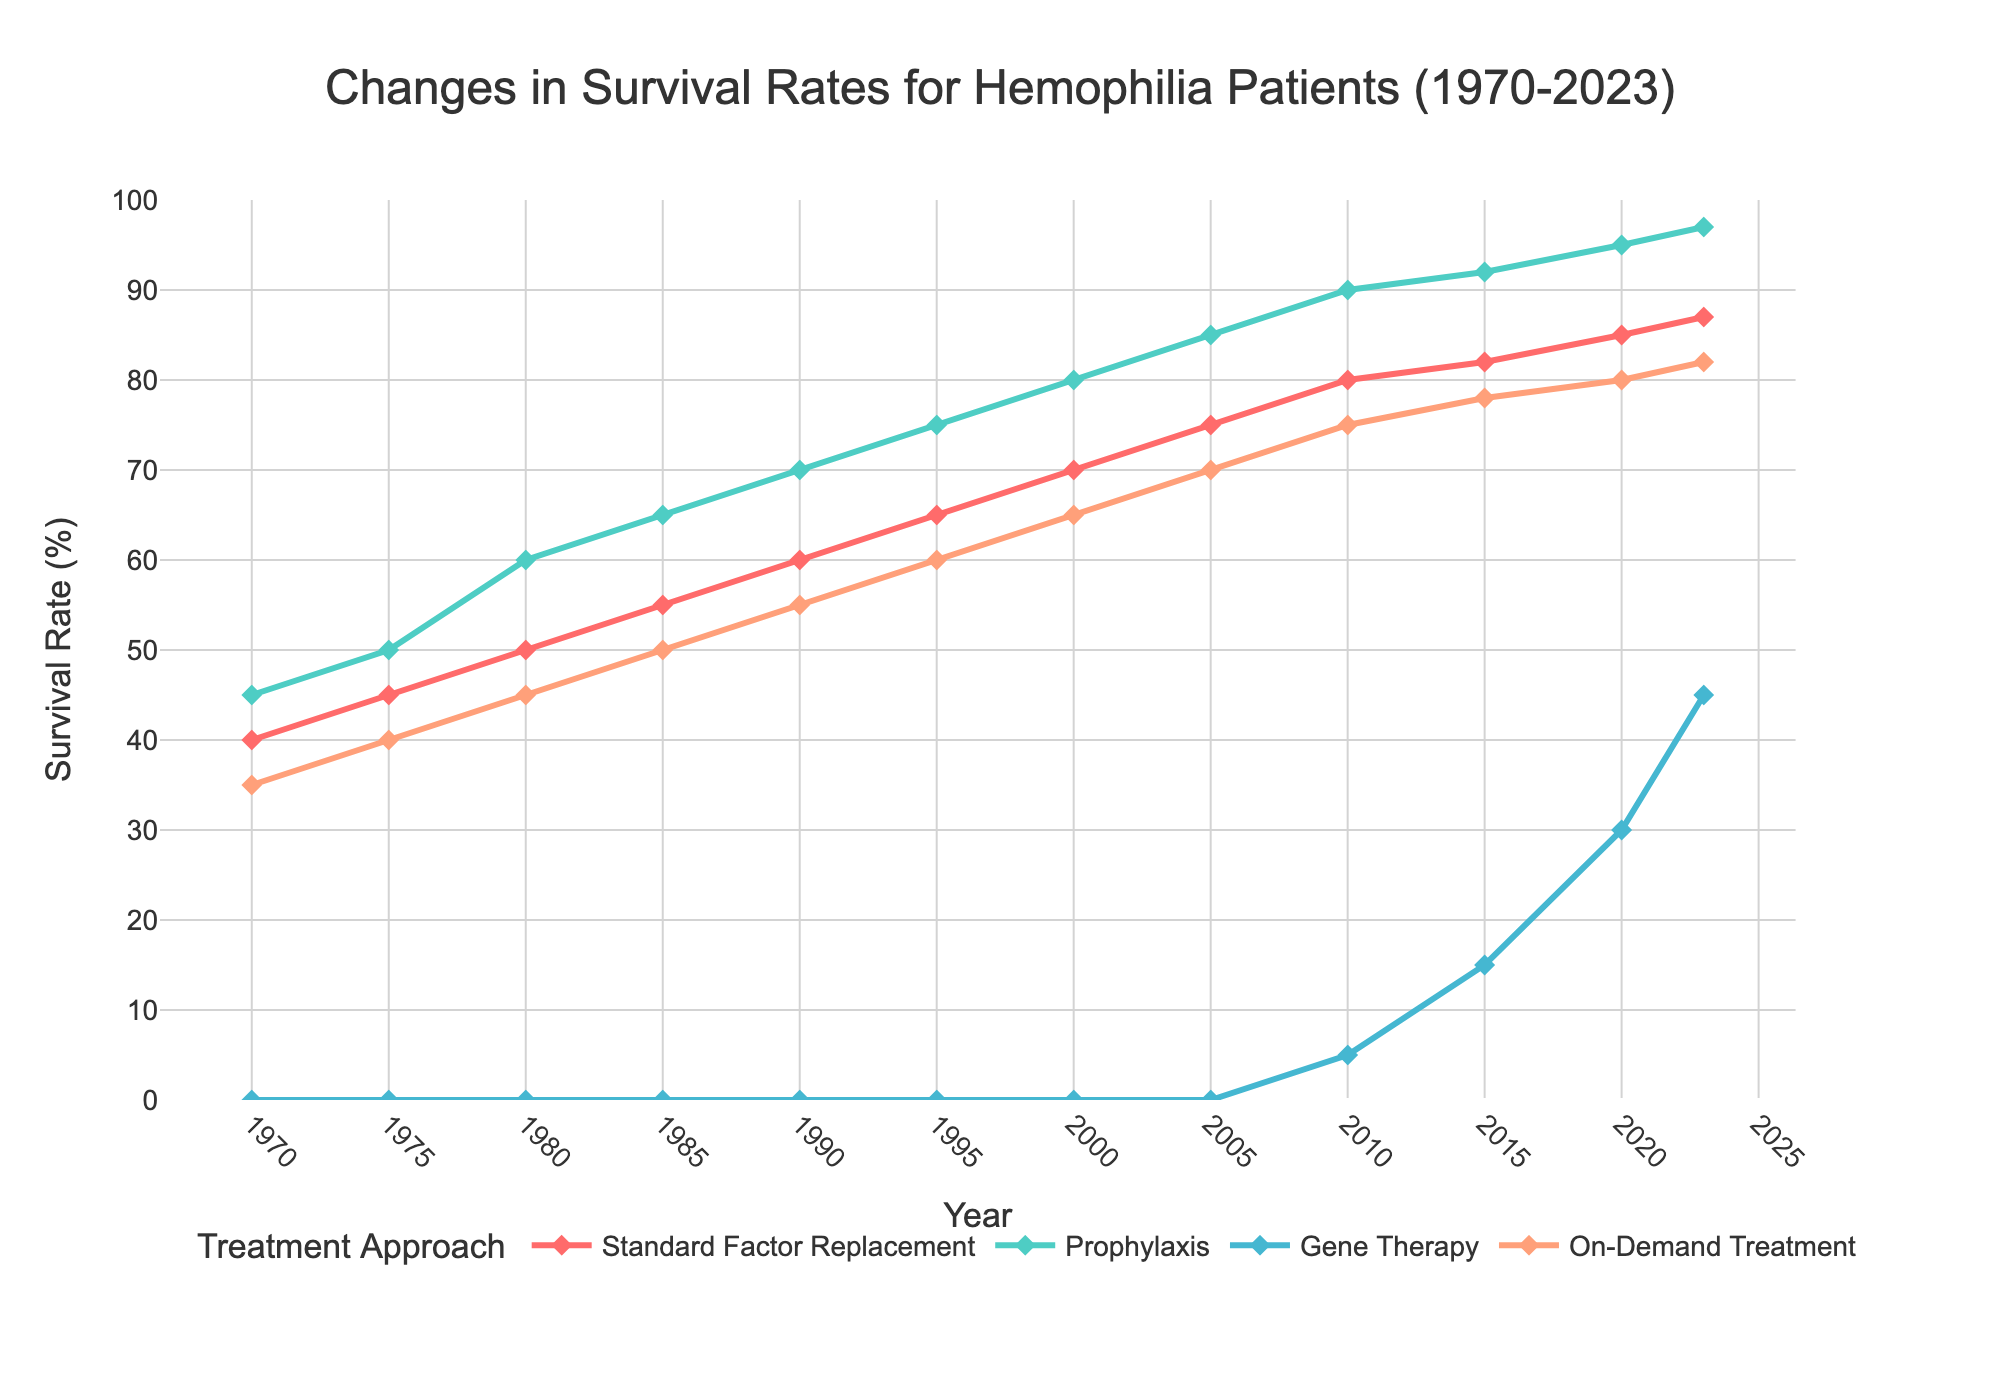What's the range of survival rates for Standard Factor Replacement from 1970 to 2023? The survival rate for Standard Factor Replacement in 1970 is 40% and in 2023 it is 87%. The range is calculated as the highest value minus the lowest value: 87% - 40% = 47%.
Answer: 47% Which treatment approach showed the greatest improvement in survival rates from 2010 to 2023? In 2010, the survival rates were 80% for Prophylaxis, 5% for Gene Therapy, 75% for On-Demand Treatment, and 80% for Standard Factor Replacement. In 2023, these rates are 87%, 97%, 45%, and 82% respectively. The increase for each treatment approach is: Gene Therapy (97% - 5% = 92%), Prophylaxis (97% - 90% = 7%), Standard Factor Replacement (87% - 80% = 7%), and On-Demand Treatment (82% - 75% = 7%). Gene Therapy shows the greatest improvement.
Answer: Gene Therapy In what year did Prophylaxis surpass a 70% survival rate? By examining the plotted data for Prophylaxis, it is seen that the survival rate surpasses 70% in the year 1985, where it is recorded at 75%.
Answer: 1985 Which treatment approach had a survival rate equal to or higher than 90% first? Referring to the graph, Prophylaxis reached a 90% survival rate in 2010.
Answer: Prophylaxis What is the difference in survival rates between Gene Therapy and On-Demand Treatment in 2023? In 2023, the survival rate for Gene Therapy is 45% and that for On-Demand Treatment is 82%. The difference is calculated as follows: 82% - 45% = 37%.
Answer: 37% Compare the survival rate improvement for Standard Factor Replacement between the decades 1970-1980 and 2000-2010. For 1970-1980, the survival rate improves from 40% to 50%, resulting in a 10% increase. For 2000-2010, the survival rate improves from 70% to 80%, also resulting in a 10% increase.
Answer: Both decades: 10% By how much did the survival rate for On-Demand Treatment increase from 1970 to 2000? In 1970, the survival rate for On-Demand Treatment was 35%, and it increased to 65% in 2000. The increase is: 65% - 35% = 30%.
Answer: 30% Approximately at what point did Gene Therapy start contributing to survival rates and what was its initial rate? Gene Therapy starts showing in the data in 2010 with an initial survival rate stated as 5%.
Answer: 2010, 5% What was the survival rate for Standard Factor Replacement in the year 2023 compared to 1990? In 1990, the survival rate for Standard Factor Replacement was 60%. By 2023, it increased to 87%. Thus, the change from 1990 to 2023 can be seen as a difference of 87% - 60% = 27%.
Answer: 27% 